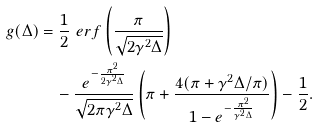<formula> <loc_0><loc_0><loc_500><loc_500>g ( \Delta ) & = \frac { 1 } { 2 } \ e r f \left ( \frac { \pi } { \sqrt { 2 \gamma ^ { 2 } \Delta } } \right ) \\ & \quad - \frac { e ^ { - \frac { \pi ^ { 2 } } { 2 \gamma ^ { 2 } \Delta } } } { \sqrt { 2 \pi \gamma ^ { 2 } \Delta } } \left ( \pi + \frac { 4 ( \pi + \gamma ^ { 2 } \Delta / \pi ) } { 1 - e ^ { - \frac { \pi ^ { 2 } } { \gamma ^ { 2 } \Delta } } } \right ) - \frac { 1 } { 2 } .</formula> 